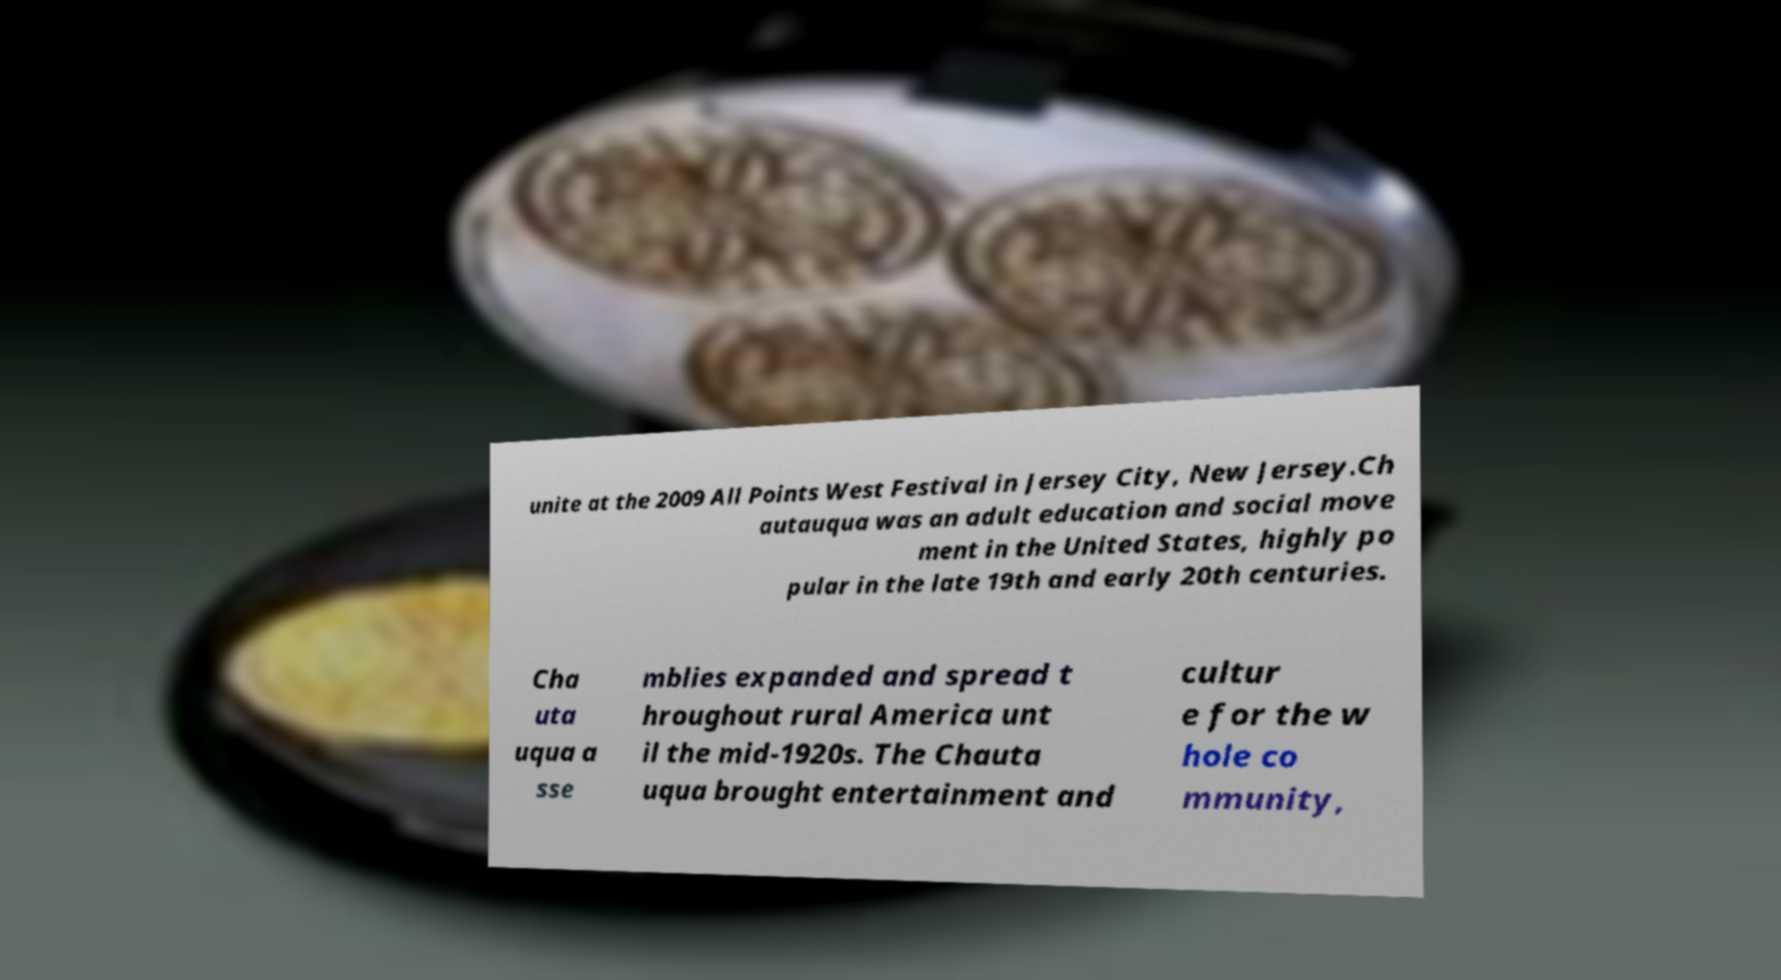I need the written content from this picture converted into text. Can you do that? unite at the 2009 All Points West Festival in Jersey City, New Jersey.Ch autauqua was an adult education and social move ment in the United States, highly po pular in the late 19th and early 20th centuries. Cha uta uqua a sse mblies expanded and spread t hroughout rural America unt il the mid-1920s. The Chauta uqua brought entertainment and cultur e for the w hole co mmunity, 